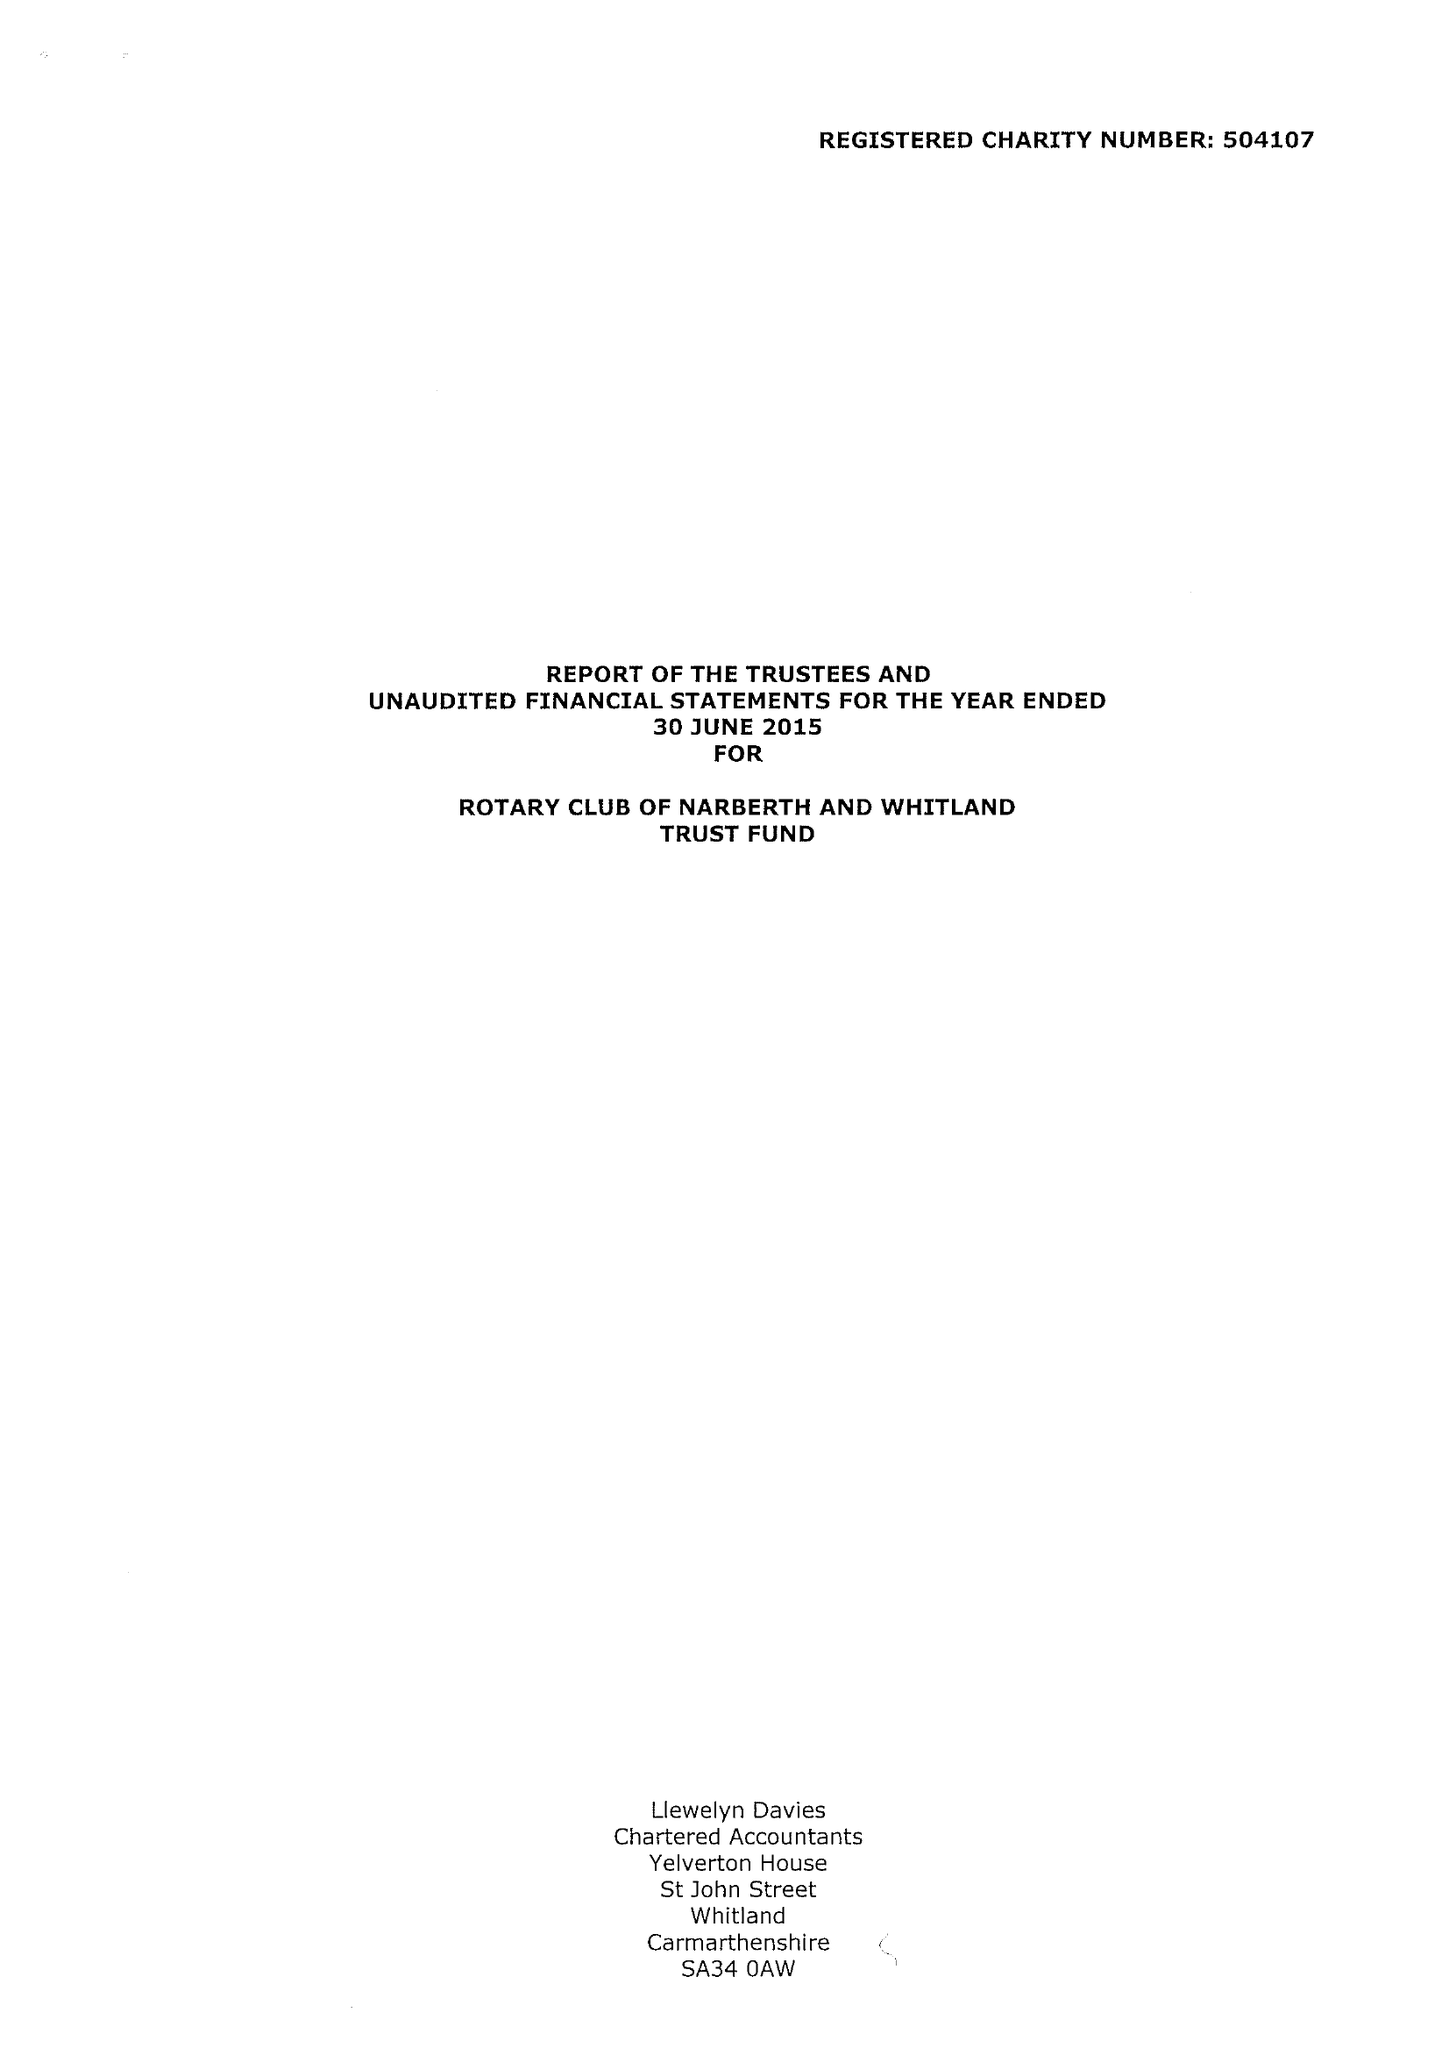What is the value for the address__post_town?
Answer the question using a single word or phrase. NARBERTH 